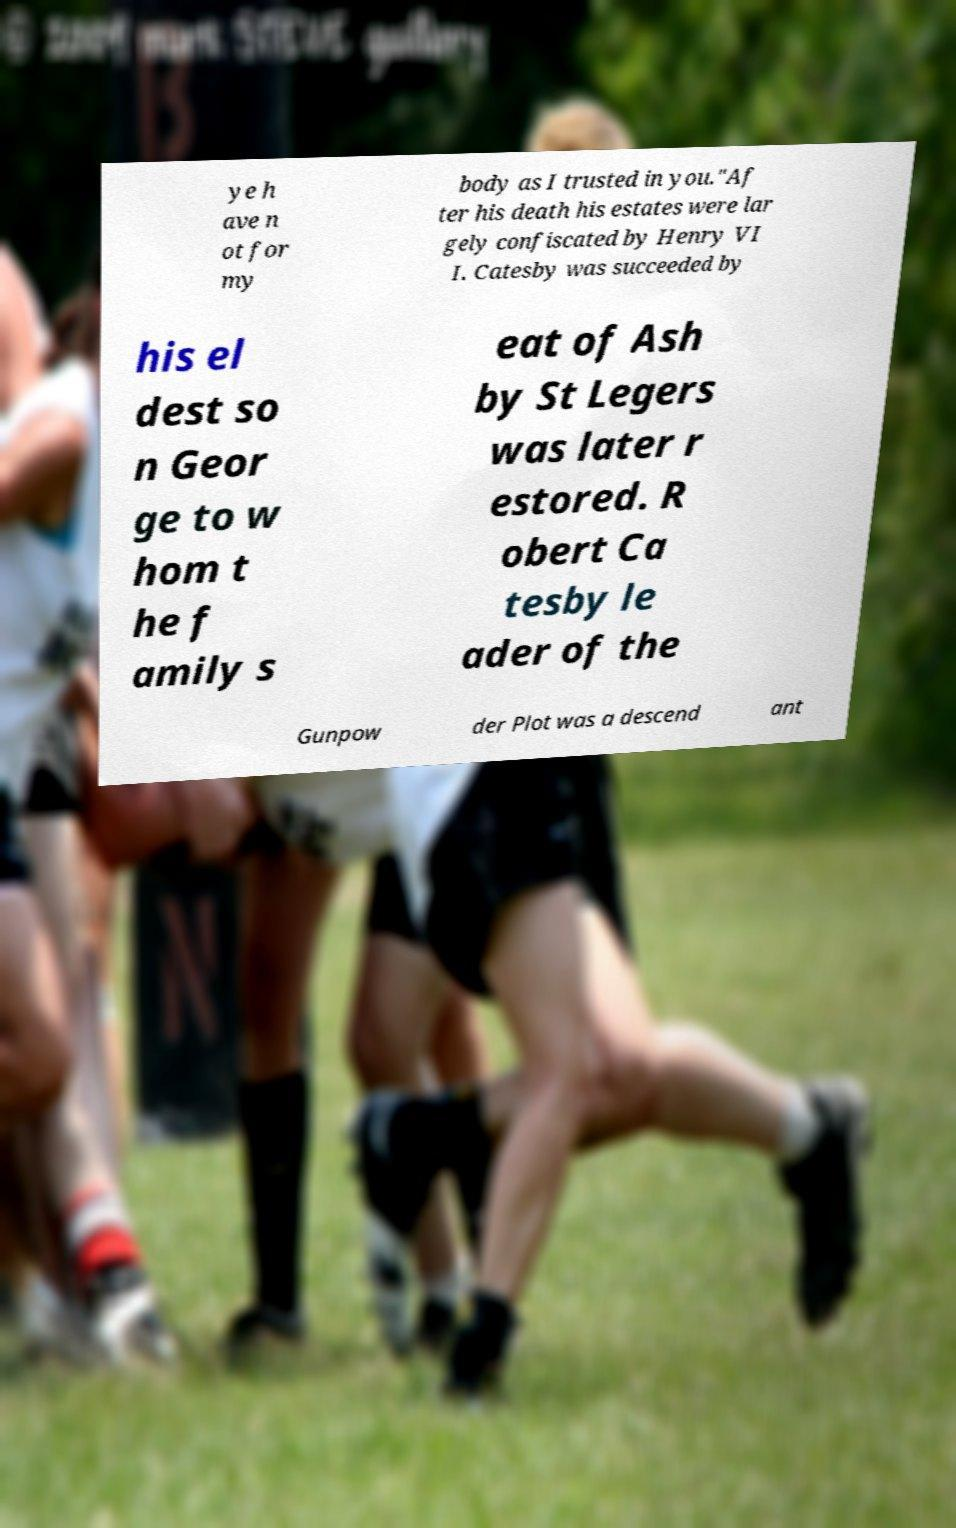For documentation purposes, I need the text within this image transcribed. Could you provide that? ye h ave n ot for my body as I trusted in you."Af ter his death his estates were lar gely confiscated by Henry VI I. Catesby was succeeded by his el dest so n Geor ge to w hom t he f amily s eat of Ash by St Legers was later r estored. R obert Ca tesby le ader of the Gunpow der Plot was a descend ant 